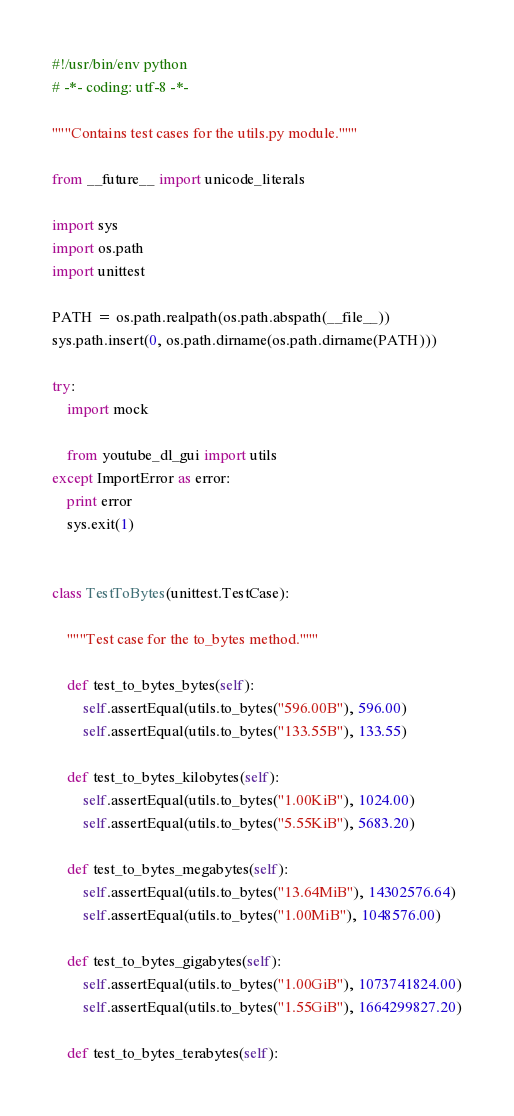Convert code to text. <code><loc_0><loc_0><loc_500><loc_500><_Python_>#!/usr/bin/env python
# -*- coding: utf-8 -*-

"""Contains test cases for the utils.py module."""

from __future__ import unicode_literals

import sys
import os.path
import unittest

PATH = os.path.realpath(os.path.abspath(__file__))
sys.path.insert(0, os.path.dirname(os.path.dirname(PATH)))

try:
    import mock

    from youtube_dl_gui import utils
except ImportError as error:
    print error
    sys.exit(1)


class TestToBytes(unittest.TestCase):

    """Test case for the to_bytes method."""

    def test_to_bytes_bytes(self):
        self.assertEqual(utils.to_bytes("596.00B"), 596.00)
        self.assertEqual(utils.to_bytes("133.55B"), 133.55)

    def test_to_bytes_kilobytes(self):
        self.assertEqual(utils.to_bytes("1.00KiB"), 1024.00)
        self.assertEqual(utils.to_bytes("5.55KiB"), 5683.20)

    def test_to_bytes_megabytes(self):
        self.assertEqual(utils.to_bytes("13.64MiB"), 14302576.64)
        self.assertEqual(utils.to_bytes("1.00MiB"), 1048576.00)

    def test_to_bytes_gigabytes(self):
        self.assertEqual(utils.to_bytes("1.00GiB"), 1073741824.00)
        self.assertEqual(utils.to_bytes("1.55GiB"), 1664299827.20)

    def test_to_bytes_terabytes(self):</code> 